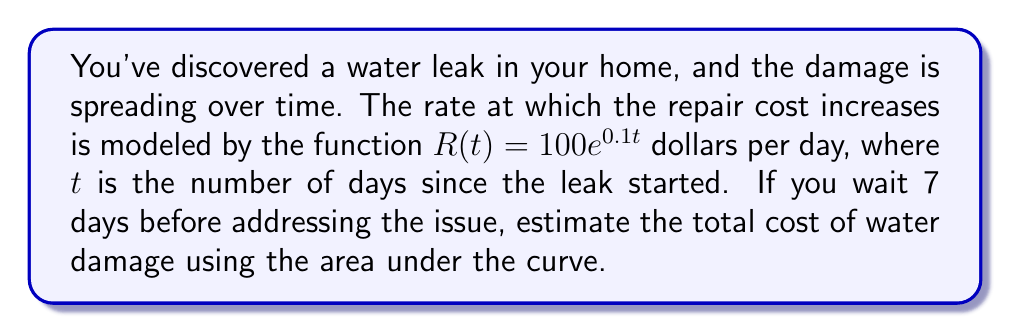Can you solve this math problem? To estimate the total cost of water damage, we need to calculate the area under the curve of the rate function $R(t) = 100e^{0.1t}$ from $t=0$ to $t=7$.

1) The total cost is given by the definite integral:

   $$C = \int_0^7 R(t) dt = \int_0^7 100e^{0.1t} dt$$

2) To solve this integral, we can use the following antiderivative:

   $$\int e^{ax} dx = \frac{1}{a}e^{ax} + C$$

3) Applying this to our integral:

   $$C = 100 \int_0^7 e^{0.1t} dt = 100 \cdot \frac{1}{0.1}e^{0.1t}\bigg|_0^7$$

4) Evaluating the definite integral:

   $$C = 1000(e^{0.1\cdot7} - e^{0.1\cdot0}) = 1000(e^{0.7} - 1)$$

5) Calculate the result:

   $$C = 1000(2.0138 - 1) = 1000 \cdot 1.0138 = 1013.80$$

Therefore, the estimated total cost of water damage after 7 days is approximately $1,013.80.
Answer: $1,013.80 